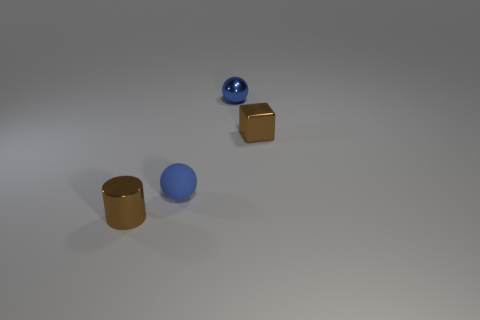How many rubber objects are the same size as the cylinder?
Your answer should be compact. 1. What number of tiny things are brown metal things or brown rubber spheres?
Make the answer very short. 2. Are there any tiny brown metallic cylinders?
Offer a terse response. Yes. Are there more balls that are to the left of the tiny rubber object than small metallic cylinders that are right of the metallic block?
Ensure brevity in your answer.  No. What is the color of the object behind the brown shiny block to the right of the small rubber object?
Provide a succinct answer. Blue. Are there any small metal objects of the same color as the cylinder?
Give a very brief answer. Yes. There is a blue thing that is behind the brown thing behind the metallic cylinder in front of the small brown metal cube; how big is it?
Your answer should be compact. Small. What is the shape of the small blue metallic thing?
Offer a terse response. Sphere. What is the size of the other object that is the same color as the tiny matte object?
Ensure brevity in your answer.  Small. There is a brown object behind the brown shiny cylinder; how many small blue shiny things are to the left of it?
Your answer should be compact. 1. 